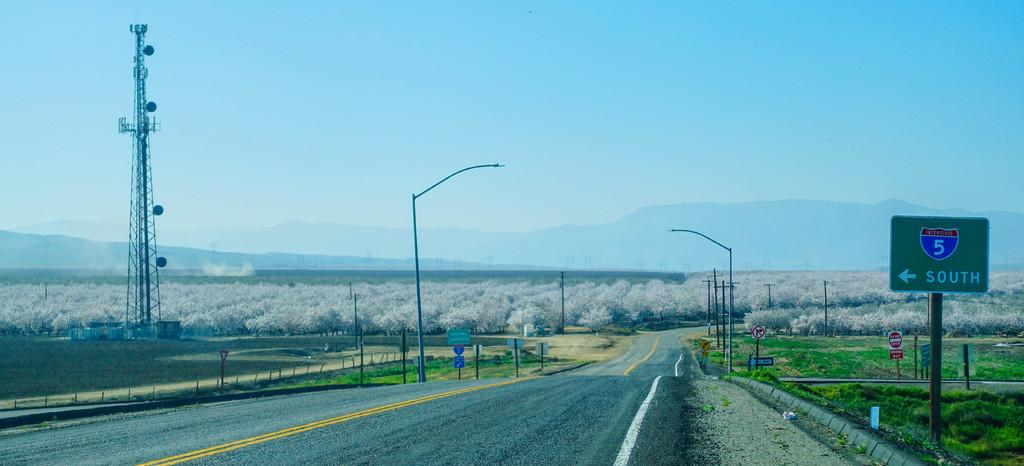What structures are present in the image? There are poles, sign boards, and a tower in the image. What can be seen in the background of the image? There are trees and hills in the background of the image. What type of cherry is hanging from the poles in the image? There are no cherries present in the image; it features poles, sign boards, and a tower. Is there a sweater draped over the tower in the image? There is no sweater present in the image; it only shows poles, sign boards, a tower, trees, and hills. 